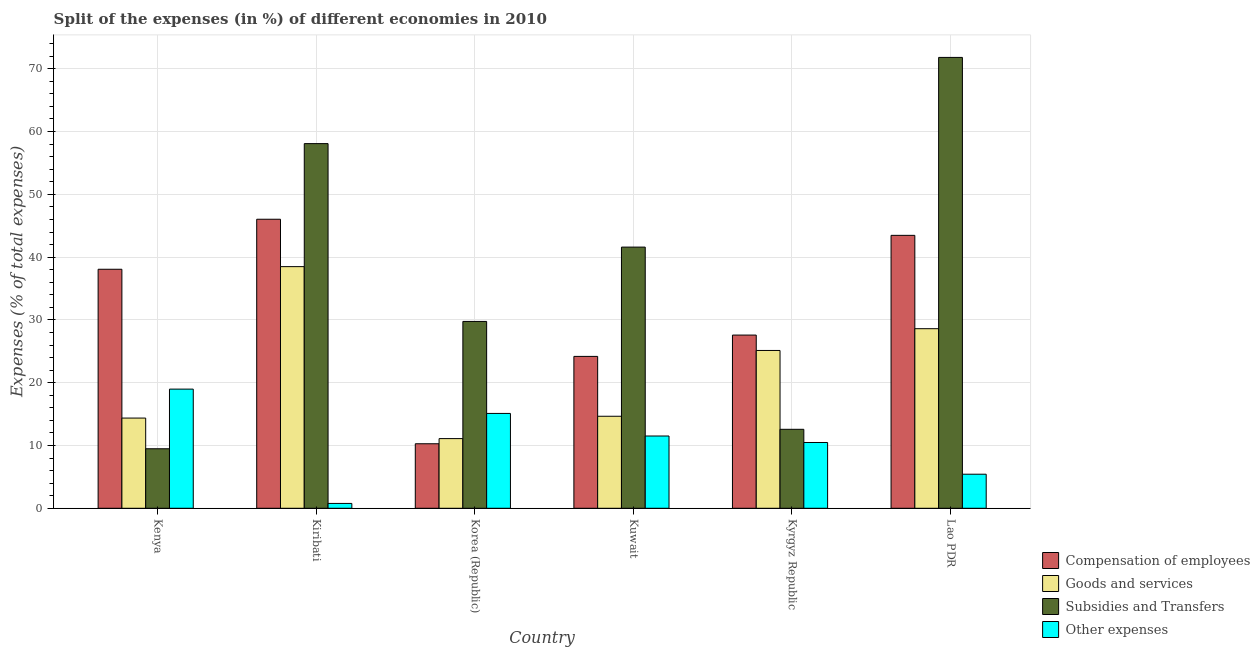How many different coloured bars are there?
Give a very brief answer. 4. Are the number of bars per tick equal to the number of legend labels?
Make the answer very short. Yes. How many bars are there on the 3rd tick from the left?
Offer a terse response. 4. How many bars are there on the 6th tick from the right?
Make the answer very short. 4. What is the percentage of amount spent on subsidies in Lao PDR?
Offer a very short reply. 71.81. Across all countries, what is the maximum percentage of amount spent on compensation of employees?
Your response must be concise. 46.03. Across all countries, what is the minimum percentage of amount spent on subsidies?
Your answer should be very brief. 9.48. In which country was the percentage of amount spent on goods and services maximum?
Ensure brevity in your answer.  Kiribati. What is the total percentage of amount spent on compensation of employees in the graph?
Your response must be concise. 189.62. What is the difference between the percentage of amount spent on goods and services in Kenya and that in Kuwait?
Provide a succinct answer. -0.29. What is the difference between the percentage of amount spent on compensation of employees in Kenya and the percentage of amount spent on goods and services in Kuwait?
Make the answer very short. 23.41. What is the average percentage of amount spent on subsidies per country?
Your answer should be very brief. 37.22. What is the difference between the percentage of amount spent on compensation of employees and percentage of amount spent on goods and services in Lao PDR?
Make the answer very short. 14.87. In how many countries, is the percentage of amount spent on other expenses greater than 38 %?
Give a very brief answer. 0. What is the ratio of the percentage of amount spent on goods and services in Kuwait to that in Kyrgyz Republic?
Provide a short and direct response. 0.58. Is the difference between the percentage of amount spent on compensation of employees in Korea (Republic) and Kyrgyz Republic greater than the difference between the percentage of amount spent on subsidies in Korea (Republic) and Kyrgyz Republic?
Your response must be concise. No. What is the difference between the highest and the second highest percentage of amount spent on subsidies?
Offer a terse response. 13.73. What is the difference between the highest and the lowest percentage of amount spent on subsidies?
Keep it short and to the point. 62.33. In how many countries, is the percentage of amount spent on other expenses greater than the average percentage of amount spent on other expenses taken over all countries?
Provide a succinct answer. 4. What does the 1st bar from the left in Lao PDR represents?
Your answer should be compact. Compensation of employees. What does the 1st bar from the right in Kuwait represents?
Provide a short and direct response. Other expenses. Is it the case that in every country, the sum of the percentage of amount spent on compensation of employees and percentage of amount spent on goods and services is greater than the percentage of amount spent on subsidies?
Provide a short and direct response. No. How many bars are there?
Provide a short and direct response. 24. Where does the legend appear in the graph?
Offer a very short reply. Bottom right. How many legend labels are there?
Your answer should be very brief. 4. How are the legend labels stacked?
Keep it short and to the point. Vertical. What is the title of the graph?
Your response must be concise. Split of the expenses (in %) of different economies in 2010. Does "SF6 gas" appear as one of the legend labels in the graph?
Give a very brief answer. No. What is the label or title of the X-axis?
Provide a short and direct response. Country. What is the label or title of the Y-axis?
Your answer should be very brief. Expenses (% of total expenses). What is the Expenses (% of total expenses) of Compensation of employees in Kenya?
Your answer should be compact. 38.07. What is the Expenses (% of total expenses) in Goods and services in Kenya?
Keep it short and to the point. 14.37. What is the Expenses (% of total expenses) of Subsidies and Transfers in Kenya?
Keep it short and to the point. 9.48. What is the Expenses (% of total expenses) of Other expenses in Kenya?
Your answer should be very brief. 18.98. What is the Expenses (% of total expenses) of Compensation of employees in Kiribati?
Provide a succinct answer. 46.03. What is the Expenses (% of total expenses) in Goods and services in Kiribati?
Offer a terse response. 38.49. What is the Expenses (% of total expenses) of Subsidies and Transfers in Kiribati?
Offer a terse response. 58.08. What is the Expenses (% of total expenses) in Other expenses in Kiribati?
Your answer should be very brief. 0.77. What is the Expenses (% of total expenses) of Compensation of employees in Korea (Republic)?
Your answer should be very brief. 10.27. What is the Expenses (% of total expenses) of Goods and services in Korea (Republic)?
Give a very brief answer. 11.1. What is the Expenses (% of total expenses) of Subsidies and Transfers in Korea (Republic)?
Your answer should be compact. 29.76. What is the Expenses (% of total expenses) in Other expenses in Korea (Republic)?
Ensure brevity in your answer.  15.11. What is the Expenses (% of total expenses) of Compensation of employees in Kuwait?
Offer a very short reply. 24.19. What is the Expenses (% of total expenses) of Goods and services in Kuwait?
Make the answer very short. 14.65. What is the Expenses (% of total expenses) in Subsidies and Transfers in Kuwait?
Provide a short and direct response. 41.6. What is the Expenses (% of total expenses) of Other expenses in Kuwait?
Your response must be concise. 11.51. What is the Expenses (% of total expenses) of Compensation of employees in Kyrgyz Republic?
Offer a very short reply. 27.59. What is the Expenses (% of total expenses) of Goods and services in Kyrgyz Republic?
Keep it short and to the point. 25.13. What is the Expenses (% of total expenses) in Subsidies and Transfers in Kyrgyz Republic?
Ensure brevity in your answer.  12.58. What is the Expenses (% of total expenses) in Other expenses in Kyrgyz Republic?
Your response must be concise. 10.48. What is the Expenses (% of total expenses) in Compensation of employees in Lao PDR?
Ensure brevity in your answer.  43.47. What is the Expenses (% of total expenses) of Goods and services in Lao PDR?
Offer a terse response. 28.6. What is the Expenses (% of total expenses) in Subsidies and Transfers in Lao PDR?
Give a very brief answer. 71.81. What is the Expenses (% of total expenses) in Other expenses in Lao PDR?
Make the answer very short. 5.42. Across all countries, what is the maximum Expenses (% of total expenses) of Compensation of employees?
Offer a terse response. 46.03. Across all countries, what is the maximum Expenses (% of total expenses) of Goods and services?
Ensure brevity in your answer.  38.49. Across all countries, what is the maximum Expenses (% of total expenses) of Subsidies and Transfers?
Offer a very short reply. 71.81. Across all countries, what is the maximum Expenses (% of total expenses) of Other expenses?
Give a very brief answer. 18.98. Across all countries, what is the minimum Expenses (% of total expenses) of Compensation of employees?
Your answer should be very brief. 10.27. Across all countries, what is the minimum Expenses (% of total expenses) in Goods and services?
Keep it short and to the point. 11.1. Across all countries, what is the minimum Expenses (% of total expenses) in Subsidies and Transfers?
Offer a terse response. 9.48. Across all countries, what is the minimum Expenses (% of total expenses) of Other expenses?
Offer a very short reply. 0.77. What is the total Expenses (% of total expenses) of Compensation of employees in the graph?
Keep it short and to the point. 189.62. What is the total Expenses (% of total expenses) in Goods and services in the graph?
Provide a succinct answer. 132.33. What is the total Expenses (% of total expenses) of Subsidies and Transfers in the graph?
Give a very brief answer. 223.29. What is the total Expenses (% of total expenses) in Other expenses in the graph?
Keep it short and to the point. 62.26. What is the difference between the Expenses (% of total expenses) in Compensation of employees in Kenya and that in Kiribati?
Ensure brevity in your answer.  -7.97. What is the difference between the Expenses (% of total expenses) in Goods and services in Kenya and that in Kiribati?
Offer a very short reply. -24.12. What is the difference between the Expenses (% of total expenses) in Subsidies and Transfers in Kenya and that in Kiribati?
Make the answer very short. -48.6. What is the difference between the Expenses (% of total expenses) of Other expenses in Kenya and that in Kiribati?
Your response must be concise. 18.2. What is the difference between the Expenses (% of total expenses) in Compensation of employees in Kenya and that in Korea (Republic)?
Ensure brevity in your answer.  27.79. What is the difference between the Expenses (% of total expenses) in Goods and services in Kenya and that in Korea (Republic)?
Ensure brevity in your answer.  3.27. What is the difference between the Expenses (% of total expenses) in Subsidies and Transfers in Kenya and that in Korea (Republic)?
Keep it short and to the point. -20.28. What is the difference between the Expenses (% of total expenses) in Other expenses in Kenya and that in Korea (Republic)?
Your answer should be very brief. 3.87. What is the difference between the Expenses (% of total expenses) of Compensation of employees in Kenya and that in Kuwait?
Offer a very short reply. 13.88. What is the difference between the Expenses (% of total expenses) of Goods and services in Kenya and that in Kuwait?
Keep it short and to the point. -0.29. What is the difference between the Expenses (% of total expenses) in Subsidies and Transfers in Kenya and that in Kuwait?
Provide a short and direct response. -32.12. What is the difference between the Expenses (% of total expenses) in Other expenses in Kenya and that in Kuwait?
Provide a short and direct response. 7.47. What is the difference between the Expenses (% of total expenses) of Compensation of employees in Kenya and that in Kyrgyz Republic?
Your answer should be very brief. 10.48. What is the difference between the Expenses (% of total expenses) in Goods and services in Kenya and that in Kyrgyz Republic?
Make the answer very short. -10.77. What is the difference between the Expenses (% of total expenses) in Subsidies and Transfers in Kenya and that in Kyrgyz Republic?
Offer a very short reply. -3.1. What is the difference between the Expenses (% of total expenses) in Other expenses in Kenya and that in Kyrgyz Republic?
Your answer should be compact. 8.5. What is the difference between the Expenses (% of total expenses) in Compensation of employees in Kenya and that in Lao PDR?
Ensure brevity in your answer.  -5.4. What is the difference between the Expenses (% of total expenses) in Goods and services in Kenya and that in Lao PDR?
Offer a terse response. -14.23. What is the difference between the Expenses (% of total expenses) of Subsidies and Transfers in Kenya and that in Lao PDR?
Make the answer very short. -62.33. What is the difference between the Expenses (% of total expenses) in Other expenses in Kenya and that in Lao PDR?
Make the answer very short. 13.55. What is the difference between the Expenses (% of total expenses) in Compensation of employees in Kiribati and that in Korea (Republic)?
Your answer should be compact. 35.76. What is the difference between the Expenses (% of total expenses) of Goods and services in Kiribati and that in Korea (Republic)?
Give a very brief answer. 27.39. What is the difference between the Expenses (% of total expenses) in Subsidies and Transfers in Kiribati and that in Korea (Republic)?
Provide a short and direct response. 28.32. What is the difference between the Expenses (% of total expenses) in Other expenses in Kiribati and that in Korea (Republic)?
Provide a succinct answer. -14.33. What is the difference between the Expenses (% of total expenses) in Compensation of employees in Kiribati and that in Kuwait?
Offer a terse response. 21.84. What is the difference between the Expenses (% of total expenses) in Goods and services in Kiribati and that in Kuwait?
Offer a terse response. 23.83. What is the difference between the Expenses (% of total expenses) in Subsidies and Transfers in Kiribati and that in Kuwait?
Make the answer very short. 16.48. What is the difference between the Expenses (% of total expenses) in Other expenses in Kiribati and that in Kuwait?
Offer a terse response. -10.74. What is the difference between the Expenses (% of total expenses) of Compensation of employees in Kiribati and that in Kyrgyz Republic?
Provide a short and direct response. 18.45. What is the difference between the Expenses (% of total expenses) in Goods and services in Kiribati and that in Kyrgyz Republic?
Your response must be concise. 13.35. What is the difference between the Expenses (% of total expenses) in Subsidies and Transfers in Kiribati and that in Kyrgyz Republic?
Provide a short and direct response. 45.5. What is the difference between the Expenses (% of total expenses) in Other expenses in Kiribati and that in Kyrgyz Republic?
Keep it short and to the point. -9.7. What is the difference between the Expenses (% of total expenses) of Compensation of employees in Kiribati and that in Lao PDR?
Provide a succinct answer. 2.56. What is the difference between the Expenses (% of total expenses) of Goods and services in Kiribati and that in Lao PDR?
Give a very brief answer. 9.88. What is the difference between the Expenses (% of total expenses) of Subsidies and Transfers in Kiribati and that in Lao PDR?
Your answer should be very brief. -13.73. What is the difference between the Expenses (% of total expenses) in Other expenses in Kiribati and that in Lao PDR?
Make the answer very short. -4.65. What is the difference between the Expenses (% of total expenses) in Compensation of employees in Korea (Republic) and that in Kuwait?
Give a very brief answer. -13.92. What is the difference between the Expenses (% of total expenses) of Goods and services in Korea (Republic) and that in Kuwait?
Provide a succinct answer. -3.56. What is the difference between the Expenses (% of total expenses) in Subsidies and Transfers in Korea (Republic) and that in Kuwait?
Your answer should be very brief. -11.84. What is the difference between the Expenses (% of total expenses) of Other expenses in Korea (Republic) and that in Kuwait?
Offer a terse response. 3.6. What is the difference between the Expenses (% of total expenses) of Compensation of employees in Korea (Republic) and that in Kyrgyz Republic?
Make the answer very short. -17.31. What is the difference between the Expenses (% of total expenses) of Goods and services in Korea (Republic) and that in Kyrgyz Republic?
Offer a terse response. -14.04. What is the difference between the Expenses (% of total expenses) in Subsidies and Transfers in Korea (Republic) and that in Kyrgyz Republic?
Provide a succinct answer. 17.18. What is the difference between the Expenses (% of total expenses) of Other expenses in Korea (Republic) and that in Kyrgyz Republic?
Your response must be concise. 4.63. What is the difference between the Expenses (% of total expenses) of Compensation of employees in Korea (Republic) and that in Lao PDR?
Give a very brief answer. -33.19. What is the difference between the Expenses (% of total expenses) in Goods and services in Korea (Republic) and that in Lao PDR?
Offer a terse response. -17.5. What is the difference between the Expenses (% of total expenses) in Subsidies and Transfers in Korea (Republic) and that in Lao PDR?
Make the answer very short. -42.05. What is the difference between the Expenses (% of total expenses) of Other expenses in Korea (Republic) and that in Lao PDR?
Your answer should be compact. 9.68. What is the difference between the Expenses (% of total expenses) in Compensation of employees in Kuwait and that in Kyrgyz Republic?
Offer a very short reply. -3.4. What is the difference between the Expenses (% of total expenses) in Goods and services in Kuwait and that in Kyrgyz Republic?
Make the answer very short. -10.48. What is the difference between the Expenses (% of total expenses) of Subsidies and Transfers in Kuwait and that in Kyrgyz Republic?
Make the answer very short. 29.02. What is the difference between the Expenses (% of total expenses) in Other expenses in Kuwait and that in Kyrgyz Republic?
Provide a short and direct response. 1.03. What is the difference between the Expenses (% of total expenses) of Compensation of employees in Kuwait and that in Lao PDR?
Ensure brevity in your answer.  -19.28. What is the difference between the Expenses (% of total expenses) in Goods and services in Kuwait and that in Lao PDR?
Give a very brief answer. -13.95. What is the difference between the Expenses (% of total expenses) in Subsidies and Transfers in Kuwait and that in Lao PDR?
Give a very brief answer. -30.21. What is the difference between the Expenses (% of total expenses) of Other expenses in Kuwait and that in Lao PDR?
Offer a terse response. 6.08. What is the difference between the Expenses (% of total expenses) in Compensation of employees in Kyrgyz Republic and that in Lao PDR?
Provide a short and direct response. -15.88. What is the difference between the Expenses (% of total expenses) in Goods and services in Kyrgyz Republic and that in Lao PDR?
Provide a succinct answer. -3.47. What is the difference between the Expenses (% of total expenses) in Subsidies and Transfers in Kyrgyz Republic and that in Lao PDR?
Your answer should be compact. -59.23. What is the difference between the Expenses (% of total expenses) of Other expenses in Kyrgyz Republic and that in Lao PDR?
Offer a very short reply. 5.05. What is the difference between the Expenses (% of total expenses) in Compensation of employees in Kenya and the Expenses (% of total expenses) in Goods and services in Kiribati?
Make the answer very short. -0.42. What is the difference between the Expenses (% of total expenses) in Compensation of employees in Kenya and the Expenses (% of total expenses) in Subsidies and Transfers in Kiribati?
Your answer should be very brief. -20.01. What is the difference between the Expenses (% of total expenses) in Compensation of employees in Kenya and the Expenses (% of total expenses) in Other expenses in Kiribati?
Ensure brevity in your answer.  37.29. What is the difference between the Expenses (% of total expenses) of Goods and services in Kenya and the Expenses (% of total expenses) of Subsidies and Transfers in Kiribati?
Make the answer very short. -43.71. What is the difference between the Expenses (% of total expenses) of Goods and services in Kenya and the Expenses (% of total expenses) of Other expenses in Kiribati?
Your answer should be very brief. 13.6. What is the difference between the Expenses (% of total expenses) of Subsidies and Transfers in Kenya and the Expenses (% of total expenses) of Other expenses in Kiribati?
Give a very brief answer. 8.71. What is the difference between the Expenses (% of total expenses) of Compensation of employees in Kenya and the Expenses (% of total expenses) of Goods and services in Korea (Republic)?
Ensure brevity in your answer.  26.97. What is the difference between the Expenses (% of total expenses) in Compensation of employees in Kenya and the Expenses (% of total expenses) in Subsidies and Transfers in Korea (Republic)?
Ensure brevity in your answer.  8.31. What is the difference between the Expenses (% of total expenses) in Compensation of employees in Kenya and the Expenses (% of total expenses) in Other expenses in Korea (Republic)?
Ensure brevity in your answer.  22.96. What is the difference between the Expenses (% of total expenses) of Goods and services in Kenya and the Expenses (% of total expenses) of Subsidies and Transfers in Korea (Republic)?
Offer a very short reply. -15.39. What is the difference between the Expenses (% of total expenses) of Goods and services in Kenya and the Expenses (% of total expenses) of Other expenses in Korea (Republic)?
Provide a succinct answer. -0.74. What is the difference between the Expenses (% of total expenses) of Subsidies and Transfers in Kenya and the Expenses (% of total expenses) of Other expenses in Korea (Republic)?
Offer a very short reply. -5.63. What is the difference between the Expenses (% of total expenses) in Compensation of employees in Kenya and the Expenses (% of total expenses) in Goods and services in Kuwait?
Keep it short and to the point. 23.41. What is the difference between the Expenses (% of total expenses) in Compensation of employees in Kenya and the Expenses (% of total expenses) in Subsidies and Transfers in Kuwait?
Provide a succinct answer. -3.53. What is the difference between the Expenses (% of total expenses) in Compensation of employees in Kenya and the Expenses (% of total expenses) in Other expenses in Kuwait?
Your answer should be compact. 26.56. What is the difference between the Expenses (% of total expenses) of Goods and services in Kenya and the Expenses (% of total expenses) of Subsidies and Transfers in Kuwait?
Make the answer very short. -27.23. What is the difference between the Expenses (% of total expenses) of Goods and services in Kenya and the Expenses (% of total expenses) of Other expenses in Kuwait?
Provide a succinct answer. 2.86. What is the difference between the Expenses (% of total expenses) in Subsidies and Transfers in Kenya and the Expenses (% of total expenses) in Other expenses in Kuwait?
Your response must be concise. -2.03. What is the difference between the Expenses (% of total expenses) of Compensation of employees in Kenya and the Expenses (% of total expenses) of Goods and services in Kyrgyz Republic?
Offer a terse response. 12.93. What is the difference between the Expenses (% of total expenses) in Compensation of employees in Kenya and the Expenses (% of total expenses) in Subsidies and Transfers in Kyrgyz Republic?
Your answer should be compact. 25.49. What is the difference between the Expenses (% of total expenses) in Compensation of employees in Kenya and the Expenses (% of total expenses) in Other expenses in Kyrgyz Republic?
Your answer should be compact. 27.59. What is the difference between the Expenses (% of total expenses) of Goods and services in Kenya and the Expenses (% of total expenses) of Subsidies and Transfers in Kyrgyz Republic?
Offer a terse response. 1.79. What is the difference between the Expenses (% of total expenses) in Goods and services in Kenya and the Expenses (% of total expenses) in Other expenses in Kyrgyz Republic?
Offer a terse response. 3.89. What is the difference between the Expenses (% of total expenses) in Subsidies and Transfers in Kenya and the Expenses (% of total expenses) in Other expenses in Kyrgyz Republic?
Give a very brief answer. -1. What is the difference between the Expenses (% of total expenses) of Compensation of employees in Kenya and the Expenses (% of total expenses) of Goods and services in Lao PDR?
Your answer should be very brief. 9.47. What is the difference between the Expenses (% of total expenses) of Compensation of employees in Kenya and the Expenses (% of total expenses) of Subsidies and Transfers in Lao PDR?
Your answer should be very brief. -33.74. What is the difference between the Expenses (% of total expenses) of Compensation of employees in Kenya and the Expenses (% of total expenses) of Other expenses in Lao PDR?
Provide a short and direct response. 32.64. What is the difference between the Expenses (% of total expenses) of Goods and services in Kenya and the Expenses (% of total expenses) of Subsidies and Transfers in Lao PDR?
Give a very brief answer. -57.44. What is the difference between the Expenses (% of total expenses) of Goods and services in Kenya and the Expenses (% of total expenses) of Other expenses in Lao PDR?
Make the answer very short. 8.94. What is the difference between the Expenses (% of total expenses) in Subsidies and Transfers in Kenya and the Expenses (% of total expenses) in Other expenses in Lao PDR?
Your response must be concise. 4.05. What is the difference between the Expenses (% of total expenses) of Compensation of employees in Kiribati and the Expenses (% of total expenses) of Goods and services in Korea (Republic)?
Your answer should be very brief. 34.94. What is the difference between the Expenses (% of total expenses) of Compensation of employees in Kiribati and the Expenses (% of total expenses) of Subsidies and Transfers in Korea (Republic)?
Make the answer very short. 16.27. What is the difference between the Expenses (% of total expenses) of Compensation of employees in Kiribati and the Expenses (% of total expenses) of Other expenses in Korea (Republic)?
Your response must be concise. 30.93. What is the difference between the Expenses (% of total expenses) of Goods and services in Kiribati and the Expenses (% of total expenses) of Subsidies and Transfers in Korea (Republic)?
Your response must be concise. 8.73. What is the difference between the Expenses (% of total expenses) in Goods and services in Kiribati and the Expenses (% of total expenses) in Other expenses in Korea (Republic)?
Provide a short and direct response. 23.38. What is the difference between the Expenses (% of total expenses) in Subsidies and Transfers in Kiribati and the Expenses (% of total expenses) in Other expenses in Korea (Republic)?
Provide a succinct answer. 42.97. What is the difference between the Expenses (% of total expenses) of Compensation of employees in Kiribati and the Expenses (% of total expenses) of Goods and services in Kuwait?
Give a very brief answer. 31.38. What is the difference between the Expenses (% of total expenses) of Compensation of employees in Kiribati and the Expenses (% of total expenses) of Subsidies and Transfers in Kuwait?
Offer a terse response. 4.44. What is the difference between the Expenses (% of total expenses) of Compensation of employees in Kiribati and the Expenses (% of total expenses) of Other expenses in Kuwait?
Give a very brief answer. 34.52. What is the difference between the Expenses (% of total expenses) of Goods and services in Kiribati and the Expenses (% of total expenses) of Subsidies and Transfers in Kuwait?
Provide a succinct answer. -3.11. What is the difference between the Expenses (% of total expenses) of Goods and services in Kiribati and the Expenses (% of total expenses) of Other expenses in Kuwait?
Offer a terse response. 26.98. What is the difference between the Expenses (% of total expenses) in Subsidies and Transfers in Kiribati and the Expenses (% of total expenses) in Other expenses in Kuwait?
Give a very brief answer. 46.57. What is the difference between the Expenses (% of total expenses) of Compensation of employees in Kiribati and the Expenses (% of total expenses) of Goods and services in Kyrgyz Republic?
Your answer should be very brief. 20.9. What is the difference between the Expenses (% of total expenses) of Compensation of employees in Kiribati and the Expenses (% of total expenses) of Subsidies and Transfers in Kyrgyz Republic?
Provide a succinct answer. 33.46. What is the difference between the Expenses (% of total expenses) of Compensation of employees in Kiribati and the Expenses (% of total expenses) of Other expenses in Kyrgyz Republic?
Make the answer very short. 35.56. What is the difference between the Expenses (% of total expenses) in Goods and services in Kiribati and the Expenses (% of total expenses) in Subsidies and Transfers in Kyrgyz Republic?
Provide a short and direct response. 25.91. What is the difference between the Expenses (% of total expenses) of Goods and services in Kiribati and the Expenses (% of total expenses) of Other expenses in Kyrgyz Republic?
Give a very brief answer. 28.01. What is the difference between the Expenses (% of total expenses) of Subsidies and Transfers in Kiribati and the Expenses (% of total expenses) of Other expenses in Kyrgyz Republic?
Offer a very short reply. 47.6. What is the difference between the Expenses (% of total expenses) of Compensation of employees in Kiribati and the Expenses (% of total expenses) of Goods and services in Lao PDR?
Your answer should be very brief. 17.43. What is the difference between the Expenses (% of total expenses) in Compensation of employees in Kiribati and the Expenses (% of total expenses) in Subsidies and Transfers in Lao PDR?
Provide a succinct answer. -25.77. What is the difference between the Expenses (% of total expenses) of Compensation of employees in Kiribati and the Expenses (% of total expenses) of Other expenses in Lao PDR?
Your response must be concise. 40.61. What is the difference between the Expenses (% of total expenses) in Goods and services in Kiribati and the Expenses (% of total expenses) in Subsidies and Transfers in Lao PDR?
Your answer should be compact. -33.32. What is the difference between the Expenses (% of total expenses) of Goods and services in Kiribati and the Expenses (% of total expenses) of Other expenses in Lao PDR?
Make the answer very short. 33.06. What is the difference between the Expenses (% of total expenses) of Subsidies and Transfers in Kiribati and the Expenses (% of total expenses) of Other expenses in Lao PDR?
Ensure brevity in your answer.  52.65. What is the difference between the Expenses (% of total expenses) of Compensation of employees in Korea (Republic) and the Expenses (% of total expenses) of Goods and services in Kuwait?
Offer a very short reply. -4.38. What is the difference between the Expenses (% of total expenses) in Compensation of employees in Korea (Republic) and the Expenses (% of total expenses) in Subsidies and Transfers in Kuwait?
Provide a succinct answer. -31.32. What is the difference between the Expenses (% of total expenses) of Compensation of employees in Korea (Republic) and the Expenses (% of total expenses) of Other expenses in Kuwait?
Provide a short and direct response. -1.23. What is the difference between the Expenses (% of total expenses) of Goods and services in Korea (Republic) and the Expenses (% of total expenses) of Subsidies and Transfers in Kuwait?
Make the answer very short. -30.5. What is the difference between the Expenses (% of total expenses) of Goods and services in Korea (Republic) and the Expenses (% of total expenses) of Other expenses in Kuwait?
Give a very brief answer. -0.41. What is the difference between the Expenses (% of total expenses) of Subsidies and Transfers in Korea (Republic) and the Expenses (% of total expenses) of Other expenses in Kuwait?
Provide a succinct answer. 18.25. What is the difference between the Expenses (% of total expenses) of Compensation of employees in Korea (Republic) and the Expenses (% of total expenses) of Goods and services in Kyrgyz Republic?
Your response must be concise. -14.86. What is the difference between the Expenses (% of total expenses) of Compensation of employees in Korea (Republic) and the Expenses (% of total expenses) of Subsidies and Transfers in Kyrgyz Republic?
Ensure brevity in your answer.  -2.3. What is the difference between the Expenses (% of total expenses) in Compensation of employees in Korea (Republic) and the Expenses (% of total expenses) in Other expenses in Kyrgyz Republic?
Provide a succinct answer. -0.2. What is the difference between the Expenses (% of total expenses) in Goods and services in Korea (Republic) and the Expenses (% of total expenses) in Subsidies and Transfers in Kyrgyz Republic?
Provide a short and direct response. -1.48. What is the difference between the Expenses (% of total expenses) of Goods and services in Korea (Republic) and the Expenses (% of total expenses) of Other expenses in Kyrgyz Republic?
Offer a very short reply. 0.62. What is the difference between the Expenses (% of total expenses) of Subsidies and Transfers in Korea (Republic) and the Expenses (% of total expenses) of Other expenses in Kyrgyz Republic?
Make the answer very short. 19.28. What is the difference between the Expenses (% of total expenses) of Compensation of employees in Korea (Republic) and the Expenses (% of total expenses) of Goods and services in Lao PDR?
Ensure brevity in your answer.  -18.33. What is the difference between the Expenses (% of total expenses) of Compensation of employees in Korea (Republic) and the Expenses (% of total expenses) of Subsidies and Transfers in Lao PDR?
Keep it short and to the point. -61.53. What is the difference between the Expenses (% of total expenses) in Compensation of employees in Korea (Republic) and the Expenses (% of total expenses) in Other expenses in Lao PDR?
Provide a succinct answer. 4.85. What is the difference between the Expenses (% of total expenses) of Goods and services in Korea (Republic) and the Expenses (% of total expenses) of Subsidies and Transfers in Lao PDR?
Your answer should be very brief. -60.71. What is the difference between the Expenses (% of total expenses) of Goods and services in Korea (Republic) and the Expenses (% of total expenses) of Other expenses in Lao PDR?
Make the answer very short. 5.67. What is the difference between the Expenses (% of total expenses) of Subsidies and Transfers in Korea (Republic) and the Expenses (% of total expenses) of Other expenses in Lao PDR?
Make the answer very short. 24.33. What is the difference between the Expenses (% of total expenses) in Compensation of employees in Kuwait and the Expenses (% of total expenses) in Goods and services in Kyrgyz Republic?
Your response must be concise. -0.94. What is the difference between the Expenses (% of total expenses) in Compensation of employees in Kuwait and the Expenses (% of total expenses) in Subsidies and Transfers in Kyrgyz Republic?
Give a very brief answer. 11.61. What is the difference between the Expenses (% of total expenses) in Compensation of employees in Kuwait and the Expenses (% of total expenses) in Other expenses in Kyrgyz Republic?
Offer a terse response. 13.71. What is the difference between the Expenses (% of total expenses) in Goods and services in Kuwait and the Expenses (% of total expenses) in Subsidies and Transfers in Kyrgyz Republic?
Give a very brief answer. 2.08. What is the difference between the Expenses (% of total expenses) in Goods and services in Kuwait and the Expenses (% of total expenses) in Other expenses in Kyrgyz Republic?
Provide a short and direct response. 4.18. What is the difference between the Expenses (% of total expenses) in Subsidies and Transfers in Kuwait and the Expenses (% of total expenses) in Other expenses in Kyrgyz Republic?
Give a very brief answer. 31.12. What is the difference between the Expenses (% of total expenses) of Compensation of employees in Kuwait and the Expenses (% of total expenses) of Goods and services in Lao PDR?
Provide a succinct answer. -4.41. What is the difference between the Expenses (% of total expenses) of Compensation of employees in Kuwait and the Expenses (% of total expenses) of Subsidies and Transfers in Lao PDR?
Provide a succinct answer. -47.62. What is the difference between the Expenses (% of total expenses) of Compensation of employees in Kuwait and the Expenses (% of total expenses) of Other expenses in Lao PDR?
Provide a short and direct response. 18.77. What is the difference between the Expenses (% of total expenses) of Goods and services in Kuwait and the Expenses (% of total expenses) of Subsidies and Transfers in Lao PDR?
Ensure brevity in your answer.  -57.15. What is the difference between the Expenses (% of total expenses) in Goods and services in Kuwait and the Expenses (% of total expenses) in Other expenses in Lao PDR?
Your answer should be compact. 9.23. What is the difference between the Expenses (% of total expenses) of Subsidies and Transfers in Kuwait and the Expenses (% of total expenses) of Other expenses in Lao PDR?
Make the answer very short. 36.17. What is the difference between the Expenses (% of total expenses) in Compensation of employees in Kyrgyz Republic and the Expenses (% of total expenses) in Goods and services in Lao PDR?
Ensure brevity in your answer.  -1.01. What is the difference between the Expenses (% of total expenses) of Compensation of employees in Kyrgyz Republic and the Expenses (% of total expenses) of Subsidies and Transfers in Lao PDR?
Offer a terse response. -44.22. What is the difference between the Expenses (% of total expenses) in Compensation of employees in Kyrgyz Republic and the Expenses (% of total expenses) in Other expenses in Lao PDR?
Keep it short and to the point. 22.16. What is the difference between the Expenses (% of total expenses) of Goods and services in Kyrgyz Republic and the Expenses (% of total expenses) of Subsidies and Transfers in Lao PDR?
Give a very brief answer. -46.67. What is the difference between the Expenses (% of total expenses) in Goods and services in Kyrgyz Republic and the Expenses (% of total expenses) in Other expenses in Lao PDR?
Keep it short and to the point. 19.71. What is the difference between the Expenses (% of total expenses) of Subsidies and Transfers in Kyrgyz Republic and the Expenses (% of total expenses) of Other expenses in Lao PDR?
Offer a terse response. 7.15. What is the average Expenses (% of total expenses) of Compensation of employees per country?
Offer a terse response. 31.6. What is the average Expenses (% of total expenses) of Goods and services per country?
Offer a very short reply. 22.06. What is the average Expenses (% of total expenses) of Subsidies and Transfers per country?
Give a very brief answer. 37.22. What is the average Expenses (% of total expenses) in Other expenses per country?
Offer a terse response. 10.38. What is the difference between the Expenses (% of total expenses) of Compensation of employees and Expenses (% of total expenses) of Goods and services in Kenya?
Your answer should be compact. 23.7. What is the difference between the Expenses (% of total expenses) of Compensation of employees and Expenses (% of total expenses) of Subsidies and Transfers in Kenya?
Provide a short and direct response. 28.59. What is the difference between the Expenses (% of total expenses) in Compensation of employees and Expenses (% of total expenses) in Other expenses in Kenya?
Offer a very short reply. 19.09. What is the difference between the Expenses (% of total expenses) of Goods and services and Expenses (% of total expenses) of Subsidies and Transfers in Kenya?
Offer a very short reply. 4.89. What is the difference between the Expenses (% of total expenses) of Goods and services and Expenses (% of total expenses) of Other expenses in Kenya?
Provide a short and direct response. -4.61. What is the difference between the Expenses (% of total expenses) in Subsidies and Transfers and Expenses (% of total expenses) in Other expenses in Kenya?
Make the answer very short. -9.5. What is the difference between the Expenses (% of total expenses) of Compensation of employees and Expenses (% of total expenses) of Goods and services in Kiribati?
Provide a short and direct response. 7.55. What is the difference between the Expenses (% of total expenses) of Compensation of employees and Expenses (% of total expenses) of Subsidies and Transfers in Kiribati?
Your response must be concise. -12.04. What is the difference between the Expenses (% of total expenses) of Compensation of employees and Expenses (% of total expenses) of Other expenses in Kiribati?
Keep it short and to the point. 45.26. What is the difference between the Expenses (% of total expenses) in Goods and services and Expenses (% of total expenses) in Subsidies and Transfers in Kiribati?
Make the answer very short. -19.59. What is the difference between the Expenses (% of total expenses) of Goods and services and Expenses (% of total expenses) of Other expenses in Kiribati?
Your answer should be compact. 37.71. What is the difference between the Expenses (% of total expenses) in Subsidies and Transfers and Expenses (% of total expenses) in Other expenses in Kiribati?
Provide a short and direct response. 57.31. What is the difference between the Expenses (% of total expenses) in Compensation of employees and Expenses (% of total expenses) in Goods and services in Korea (Republic)?
Provide a short and direct response. -0.82. What is the difference between the Expenses (% of total expenses) in Compensation of employees and Expenses (% of total expenses) in Subsidies and Transfers in Korea (Republic)?
Make the answer very short. -19.48. What is the difference between the Expenses (% of total expenses) in Compensation of employees and Expenses (% of total expenses) in Other expenses in Korea (Republic)?
Your answer should be very brief. -4.83. What is the difference between the Expenses (% of total expenses) in Goods and services and Expenses (% of total expenses) in Subsidies and Transfers in Korea (Republic)?
Give a very brief answer. -18.66. What is the difference between the Expenses (% of total expenses) in Goods and services and Expenses (% of total expenses) in Other expenses in Korea (Republic)?
Offer a terse response. -4.01. What is the difference between the Expenses (% of total expenses) of Subsidies and Transfers and Expenses (% of total expenses) of Other expenses in Korea (Republic)?
Offer a terse response. 14.65. What is the difference between the Expenses (% of total expenses) in Compensation of employees and Expenses (% of total expenses) in Goods and services in Kuwait?
Give a very brief answer. 9.54. What is the difference between the Expenses (% of total expenses) in Compensation of employees and Expenses (% of total expenses) in Subsidies and Transfers in Kuwait?
Give a very brief answer. -17.41. What is the difference between the Expenses (% of total expenses) of Compensation of employees and Expenses (% of total expenses) of Other expenses in Kuwait?
Your answer should be very brief. 12.68. What is the difference between the Expenses (% of total expenses) of Goods and services and Expenses (% of total expenses) of Subsidies and Transfers in Kuwait?
Offer a terse response. -26.94. What is the difference between the Expenses (% of total expenses) of Goods and services and Expenses (% of total expenses) of Other expenses in Kuwait?
Your response must be concise. 3.15. What is the difference between the Expenses (% of total expenses) in Subsidies and Transfers and Expenses (% of total expenses) in Other expenses in Kuwait?
Ensure brevity in your answer.  30.09. What is the difference between the Expenses (% of total expenses) of Compensation of employees and Expenses (% of total expenses) of Goods and services in Kyrgyz Republic?
Keep it short and to the point. 2.45. What is the difference between the Expenses (% of total expenses) in Compensation of employees and Expenses (% of total expenses) in Subsidies and Transfers in Kyrgyz Republic?
Make the answer very short. 15.01. What is the difference between the Expenses (% of total expenses) in Compensation of employees and Expenses (% of total expenses) in Other expenses in Kyrgyz Republic?
Your answer should be compact. 17.11. What is the difference between the Expenses (% of total expenses) in Goods and services and Expenses (% of total expenses) in Subsidies and Transfers in Kyrgyz Republic?
Offer a terse response. 12.56. What is the difference between the Expenses (% of total expenses) in Goods and services and Expenses (% of total expenses) in Other expenses in Kyrgyz Republic?
Your answer should be very brief. 14.66. What is the difference between the Expenses (% of total expenses) in Subsidies and Transfers and Expenses (% of total expenses) in Other expenses in Kyrgyz Republic?
Offer a terse response. 2.1. What is the difference between the Expenses (% of total expenses) in Compensation of employees and Expenses (% of total expenses) in Goods and services in Lao PDR?
Your answer should be very brief. 14.87. What is the difference between the Expenses (% of total expenses) of Compensation of employees and Expenses (% of total expenses) of Subsidies and Transfers in Lao PDR?
Your answer should be compact. -28.34. What is the difference between the Expenses (% of total expenses) in Compensation of employees and Expenses (% of total expenses) in Other expenses in Lao PDR?
Your answer should be compact. 38.04. What is the difference between the Expenses (% of total expenses) of Goods and services and Expenses (% of total expenses) of Subsidies and Transfers in Lao PDR?
Provide a short and direct response. -43.21. What is the difference between the Expenses (% of total expenses) in Goods and services and Expenses (% of total expenses) in Other expenses in Lao PDR?
Offer a very short reply. 23.18. What is the difference between the Expenses (% of total expenses) of Subsidies and Transfers and Expenses (% of total expenses) of Other expenses in Lao PDR?
Offer a terse response. 66.38. What is the ratio of the Expenses (% of total expenses) in Compensation of employees in Kenya to that in Kiribati?
Your response must be concise. 0.83. What is the ratio of the Expenses (% of total expenses) of Goods and services in Kenya to that in Kiribati?
Give a very brief answer. 0.37. What is the ratio of the Expenses (% of total expenses) in Subsidies and Transfers in Kenya to that in Kiribati?
Make the answer very short. 0.16. What is the ratio of the Expenses (% of total expenses) in Other expenses in Kenya to that in Kiribati?
Offer a very short reply. 24.61. What is the ratio of the Expenses (% of total expenses) of Compensation of employees in Kenya to that in Korea (Republic)?
Keep it short and to the point. 3.71. What is the ratio of the Expenses (% of total expenses) in Goods and services in Kenya to that in Korea (Republic)?
Provide a succinct answer. 1.29. What is the ratio of the Expenses (% of total expenses) in Subsidies and Transfers in Kenya to that in Korea (Republic)?
Provide a succinct answer. 0.32. What is the ratio of the Expenses (% of total expenses) in Other expenses in Kenya to that in Korea (Republic)?
Ensure brevity in your answer.  1.26. What is the ratio of the Expenses (% of total expenses) in Compensation of employees in Kenya to that in Kuwait?
Your answer should be compact. 1.57. What is the ratio of the Expenses (% of total expenses) in Goods and services in Kenya to that in Kuwait?
Provide a short and direct response. 0.98. What is the ratio of the Expenses (% of total expenses) of Subsidies and Transfers in Kenya to that in Kuwait?
Provide a short and direct response. 0.23. What is the ratio of the Expenses (% of total expenses) in Other expenses in Kenya to that in Kuwait?
Your answer should be compact. 1.65. What is the ratio of the Expenses (% of total expenses) of Compensation of employees in Kenya to that in Kyrgyz Republic?
Your response must be concise. 1.38. What is the ratio of the Expenses (% of total expenses) of Goods and services in Kenya to that in Kyrgyz Republic?
Offer a terse response. 0.57. What is the ratio of the Expenses (% of total expenses) of Subsidies and Transfers in Kenya to that in Kyrgyz Republic?
Keep it short and to the point. 0.75. What is the ratio of the Expenses (% of total expenses) of Other expenses in Kenya to that in Kyrgyz Republic?
Offer a terse response. 1.81. What is the ratio of the Expenses (% of total expenses) in Compensation of employees in Kenya to that in Lao PDR?
Offer a terse response. 0.88. What is the ratio of the Expenses (% of total expenses) of Goods and services in Kenya to that in Lao PDR?
Offer a terse response. 0.5. What is the ratio of the Expenses (% of total expenses) of Subsidies and Transfers in Kenya to that in Lao PDR?
Your response must be concise. 0.13. What is the ratio of the Expenses (% of total expenses) of Other expenses in Kenya to that in Lao PDR?
Offer a very short reply. 3.5. What is the ratio of the Expenses (% of total expenses) of Compensation of employees in Kiribati to that in Korea (Republic)?
Offer a terse response. 4.48. What is the ratio of the Expenses (% of total expenses) of Goods and services in Kiribati to that in Korea (Republic)?
Your response must be concise. 3.47. What is the ratio of the Expenses (% of total expenses) in Subsidies and Transfers in Kiribati to that in Korea (Republic)?
Your answer should be compact. 1.95. What is the ratio of the Expenses (% of total expenses) in Other expenses in Kiribati to that in Korea (Republic)?
Provide a succinct answer. 0.05. What is the ratio of the Expenses (% of total expenses) of Compensation of employees in Kiribati to that in Kuwait?
Offer a terse response. 1.9. What is the ratio of the Expenses (% of total expenses) in Goods and services in Kiribati to that in Kuwait?
Ensure brevity in your answer.  2.63. What is the ratio of the Expenses (% of total expenses) in Subsidies and Transfers in Kiribati to that in Kuwait?
Ensure brevity in your answer.  1.4. What is the ratio of the Expenses (% of total expenses) of Other expenses in Kiribati to that in Kuwait?
Offer a terse response. 0.07. What is the ratio of the Expenses (% of total expenses) in Compensation of employees in Kiribati to that in Kyrgyz Republic?
Keep it short and to the point. 1.67. What is the ratio of the Expenses (% of total expenses) in Goods and services in Kiribati to that in Kyrgyz Republic?
Make the answer very short. 1.53. What is the ratio of the Expenses (% of total expenses) in Subsidies and Transfers in Kiribati to that in Kyrgyz Republic?
Provide a short and direct response. 4.62. What is the ratio of the Expenses (% of total expenses) in Other expenses in Kiribati to that in Kyrgyz Republic?
Keep it short and to the point. 0.07. What is the ratio of the Expenses (% of total expenses) of Compensation of employees in Kiribati to that in Lao PDR?
Make the answer very short. 1.06. What is the ratio of the Expenses (% of total expenses) of Goods and services in Kiribati to that in Lao PDR?
Ensure brevity in your answer.  1.35. What is the ratio of the Expenses (% of total expenses) of Subsidies and Transfers in Kiribati to that in Lao PDR?
Your answer should be compact. 0.81. What is the ratio of the Expenses (% of total expenses) of Other expenses in Kiribati to that in Lao PDR?
Keep it short and to the point. 0.14. What is the ratio of the Expenses (% of total expenses) in Compensation of employees in Korea (Republic) to that in Kuwait?
Provide a short and direct response. 0.42. What is the ratio of the Expenses (% of total expenses) in Goods and services in Korea (Republic) to that in Kuwait?
Your answer should be compact. 0.76. What is the ratio of the Expenses (% of total expenses) in Subsidies and Transfers in Korea (Republic) to that in Kuwait?
Ensure brevity in your answer.  0.72. What is the ratio of the Expenses (% of total expenses) of Other expenses in Korea (Republic) to that in Kuwait?
Provide a succinct answer. 1.31. What is the ratio of the Expenses (% of total expenses) of Compensation of employees in Korea (Republic) to that in Kyrgyz Republic?
Offer a terse response. 0.37. What is the ratio of the Expenses (% of total expenses) of Goods and services in Korea (Republic) to that in Kyrgyz Republic?
Your answer should be compact. 0.44. What is the ratio of the Expenses (% of total expenses) of Subsidies and Transfers in Korea (Republic) to that in Kyrgyz Republic?
Offer a very short reply. 2.37. What is the ratio of the Expenses (% of total expenses) of Other expenses in Korea (Republic) to that in Kyrgyz Republic?
Offer a terse response. 1.44. What is the ratio of the Expenses (% of total expenses) of Compensation of employees in Korea (Republic) to that in Lao PDR?
Your response must be concise. 0.24. What is the ratio of the Expenses (% of total expenses) in Goods and services in Korea (Republic) to that in Lao PDR?
Offer a terse response. 0.39. What is the ratio of the Expenses (% of total expenses) of Subsidies and Transfers in Korea (Republic) to that in Lao PDR?
Give a very brief answer. 0.41. What is the ratio of the Expenses (% of total expenses) in Other expenses in Korea (Republic) to that in Lao PDR?
Give a very brief answer. 2.78. What is the ratio of the Expenses (% of total expenses) in Compensation of employees in Kuwait to that in Kyrgyz Republic?
Give a very brief answer. 0.88. What is the ratio of the Expenses (% of total expenses) in Goods and services in Kuwait to that in Kyrgyz Republic?
Make the answer very short. 0.58. What is the ratio of the Expenses (% of total expenses) of Subsidies and Transfers in Kuwait to that in Kyrgyz Republic?
Keep it short and to the point. 3.31. What is the ratio of the Expenses (% of total expenses) of Other expenses in Kuwait to that in Kyrgyz Republic?
Provide a succinct answer. 1.1. What is the ratio of the Expenses (% of total expenses) of Compensation of employees in Kuwait to that in Lao PDR?
Keep it short and to the point. 0.56. What is the ratio of the Expenses (% of total expenses) of Goods and services in Kuwait to that in Lao PDR?
Your response must be concise. 0.51. What is the ratio of the Expenses (% of total expenses) of Subsidies and Transfers in Kuwait to that in Lao PDR?
Ensure brevity in your answer.  0.58. What is the ratio of the Expenses (% of total expenses) in Other expenses in Kuwait to that in Lao PDR?
Provide a short and direct response. 2.12. What is the ratio of the Expenses (% of total expenses) of Compensation of employees in Kyrgyz Republic to that in Lao PDR?
Ensure brevity in your answer.  0.63. What is the ratio of the Expenses (% of total expenses) of Goods and services in Kyrgyz Republic to that in Lao PDR?
Your answer should be compact. 0.88. What is the ratio of the Expenses (% of total expenses) in Subsidies and Transfers in Kyrgyz Republic to that in Lao PDR?
Give a very brief answer. 0.18. What is the ratio of the Expenses (% of total expenses) of Other expenses in Kyrgyz Republic to that in Lao PDR?
Provide a succinct answer. 1.93. What is the difference between the highest and the second highest Expenses (% of total expenses) in Compensation of employees?
Make the answer very short. 2.56. What is the difference between the highest and the second highest Expenses (% of total expenses) of Goods and services?
Give a very brief answer. 9.88. What is the difference between the highest and the second highest Expenses (% of total expenses) in Subsidies and Transfers?
Your answer should be compact. 13.73. What is the difference between the highest and the second highest Expenses (% of total expenses) in Other expenses?
Offer a terse response. 3.87. What is the difference between the highest and the lowest Expenses (% of total expenses) in Compensation of employees?
Ensure brevity in your answer.  35.76. What is the difference between the highest and the lowest Expenses (% of total expenses) in Goods and services?
Offer a terse response. 27.39. What is the difference between the highest and the lowest Expenses (% of total expenses) of Subsidies and Transfers?
Provide a short and direct response. 62.33. What is the difference between the highest and the lowest Expenses (% of total expenses) in Other expenses?
Provide a succinct answer. 18.2. 